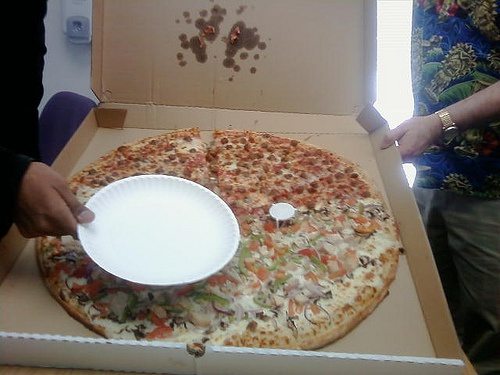Describe the objects in this image and their specific colors. I can see pizza in black, white, gray, tan, and darkgray tones, people in black, gray, navy, and darkgray tones, people in black, brown, maroon, and gray tones, chair in black, navy, gray, and purple tones, and clock in black and gray tones in this image. 